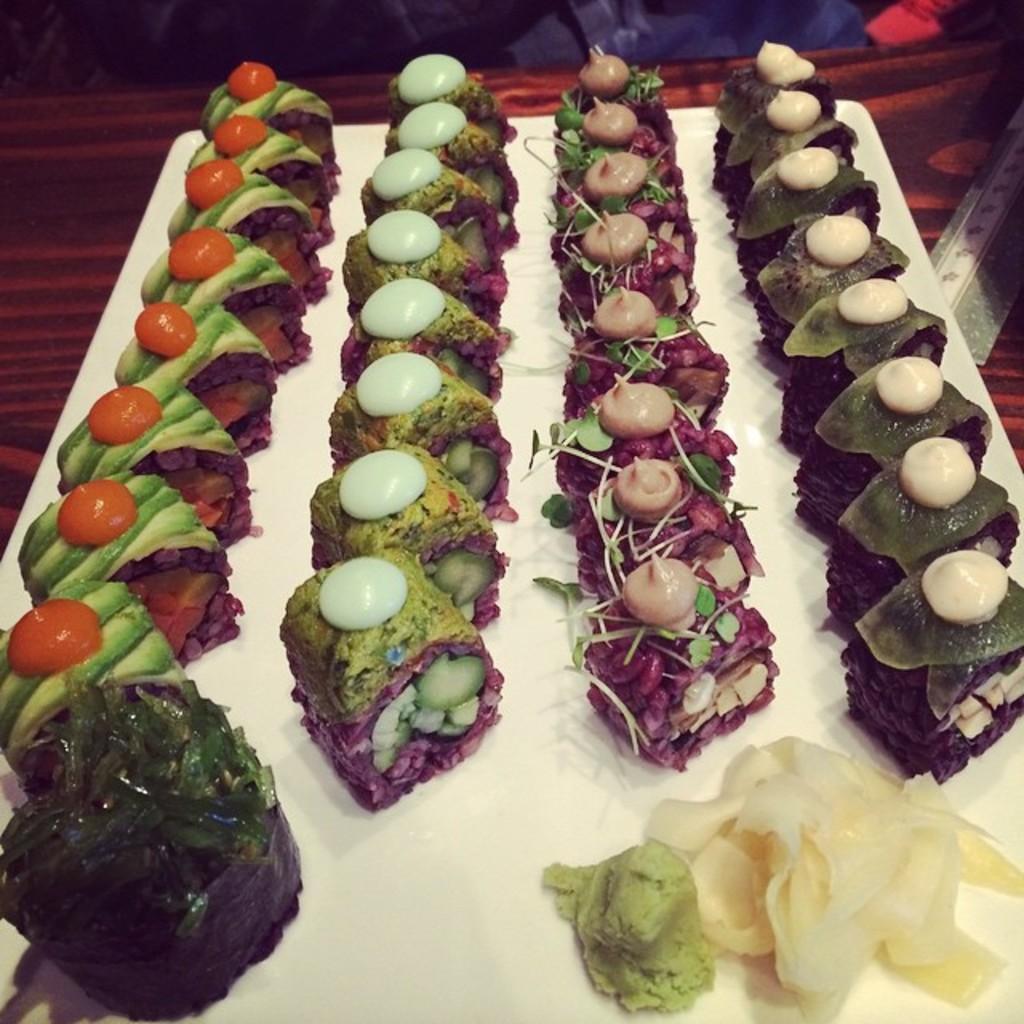Can you describe this image briefly? In this picture I can see food items on the plate, on an object, and in the background there are some items. 